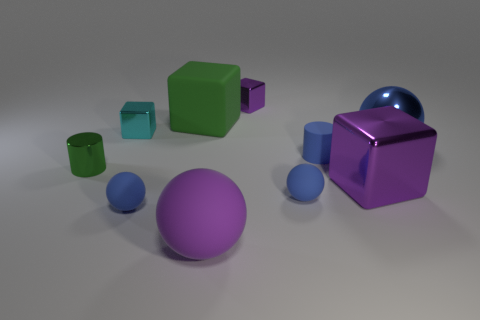There is a tiny cylinder that is made of the same material as the tiny purple object; what is its color?
Provide a short and direct response. Green. Do the blue matte cylinder and the cyan block have the same size?
Provide a short and direct response. Yes. What is the cyan object made of?
Your response must be concise. Metal. What is the material of the cyan cube that is the same size as the green cylinder?
Ensure brevity in your answer.  Metal. Is there a purple block that has the same size as the green shiny cylinder?
Ensure brevity in your answer.  Yes. Are there an equal number of big things that are in front of the big blue sphere and big green things behind the small purple cube?
Keep it short and to the point. No. Are there more big cubes than purple rubber spheres?
Your answer should be compact. Yes. What number of shiny things are either large purple blocks or small cylinders?
Offer a very short reply. 2. How many metallic things have the same color as the matte cylinder?
Ensure brevity in your answer.  1. The small block left of the large matte object in front of the purple block that is in front of the tiny cyan metal object is made of what material?
Your response must be concise. Metal. 